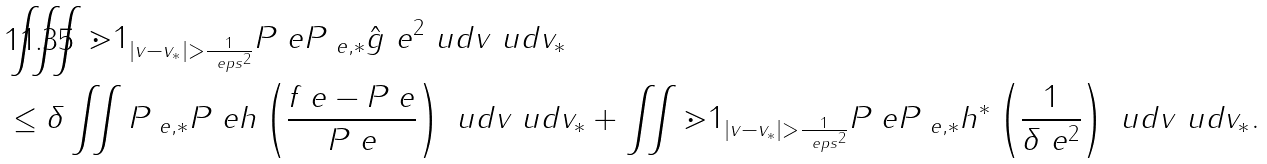Convert formula to latex. <formula><loc_0><loc_0><loc_500><loc_500>& \iiint \mathbb { m } { 1 } _ { | v - v _ { * } | > \frac { 1 } { \ e p s ^ { 2 } } } P _ { \ } e P _ { \ e , * } \hat { g } _ { \ } e ^ { 2 } \ u d v \ u d v _ { * } \\ & \leq \delta \iint P _ { \ e , * } P _ { \ } e h \left ( \frac { f _ { \ } e - P _ { \ } e } { P _ { \ } e } \right ) \ u d v \ u d v _ { * } + \iint \mathbb { m } { 1 } _ { | v - v _ { * } | > \frac { 1 } { \ e p s ^ { 2 } } } P _ { \ } e P _ { \ e , * } h ^ { * } \left ( \frac { 1 } { \delta \ e ^ { 2 } } \right ) \ u d v \ u d v _ { * } .</formula> 